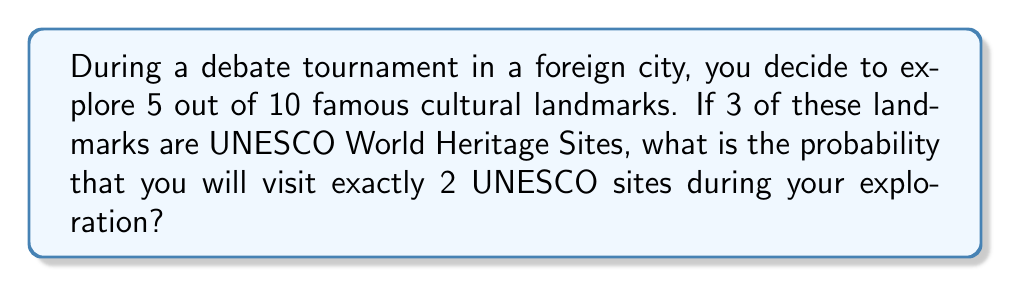Can you answer this question? Let's approach this step-by-step using the hypergeometric distribution:

1) We have a total of 10 landmarks, of which 3 are UNESCO sites.
2) We are selecting 5 landmarks to visit.
3) We want the probability of selecting exactly 2 UNESCO sites.

The probability is given by the formula:

$$ P(X=k) = \frac{\binom{K}{k} \binom{N-K}{n-k}}{\binom{N}{n}} $$

Where:
- $N$ = total number of landmarks = 10
- $K$ = number of UNESCO sites = 3
- $n$ = number of landmarks visited = 5
- $k$ = number of UNESCO sites we want to visit = 2

Let's calculate each combination:

1) $\binom{K}{k} = \binom{3}{2} = 3$
2) $\binom{N-K}{n-k} = \binom{7}{3} = 35$
3) $\binom{N}{n} = \binom{10}{5} = 252$

Now, let's substitute these values into our formula:

$$ P(X=2) = \frac{3 \times 35}{252} = \frac{105}{252} $$

Simplifying the fraction:

$$ P(X=2) = \frac{5}{12} \approx 0.4167 $$
Answer: $\frac{5}{12}$ 